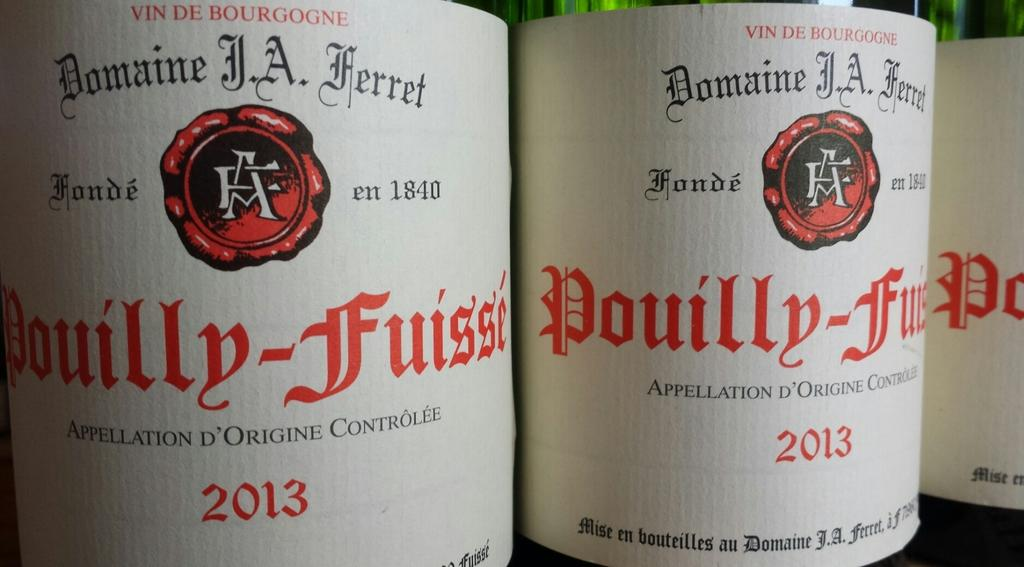<image>
Provide a brief description of the given image. Bottles of alcohol next to one another with the year 2013 on them. 